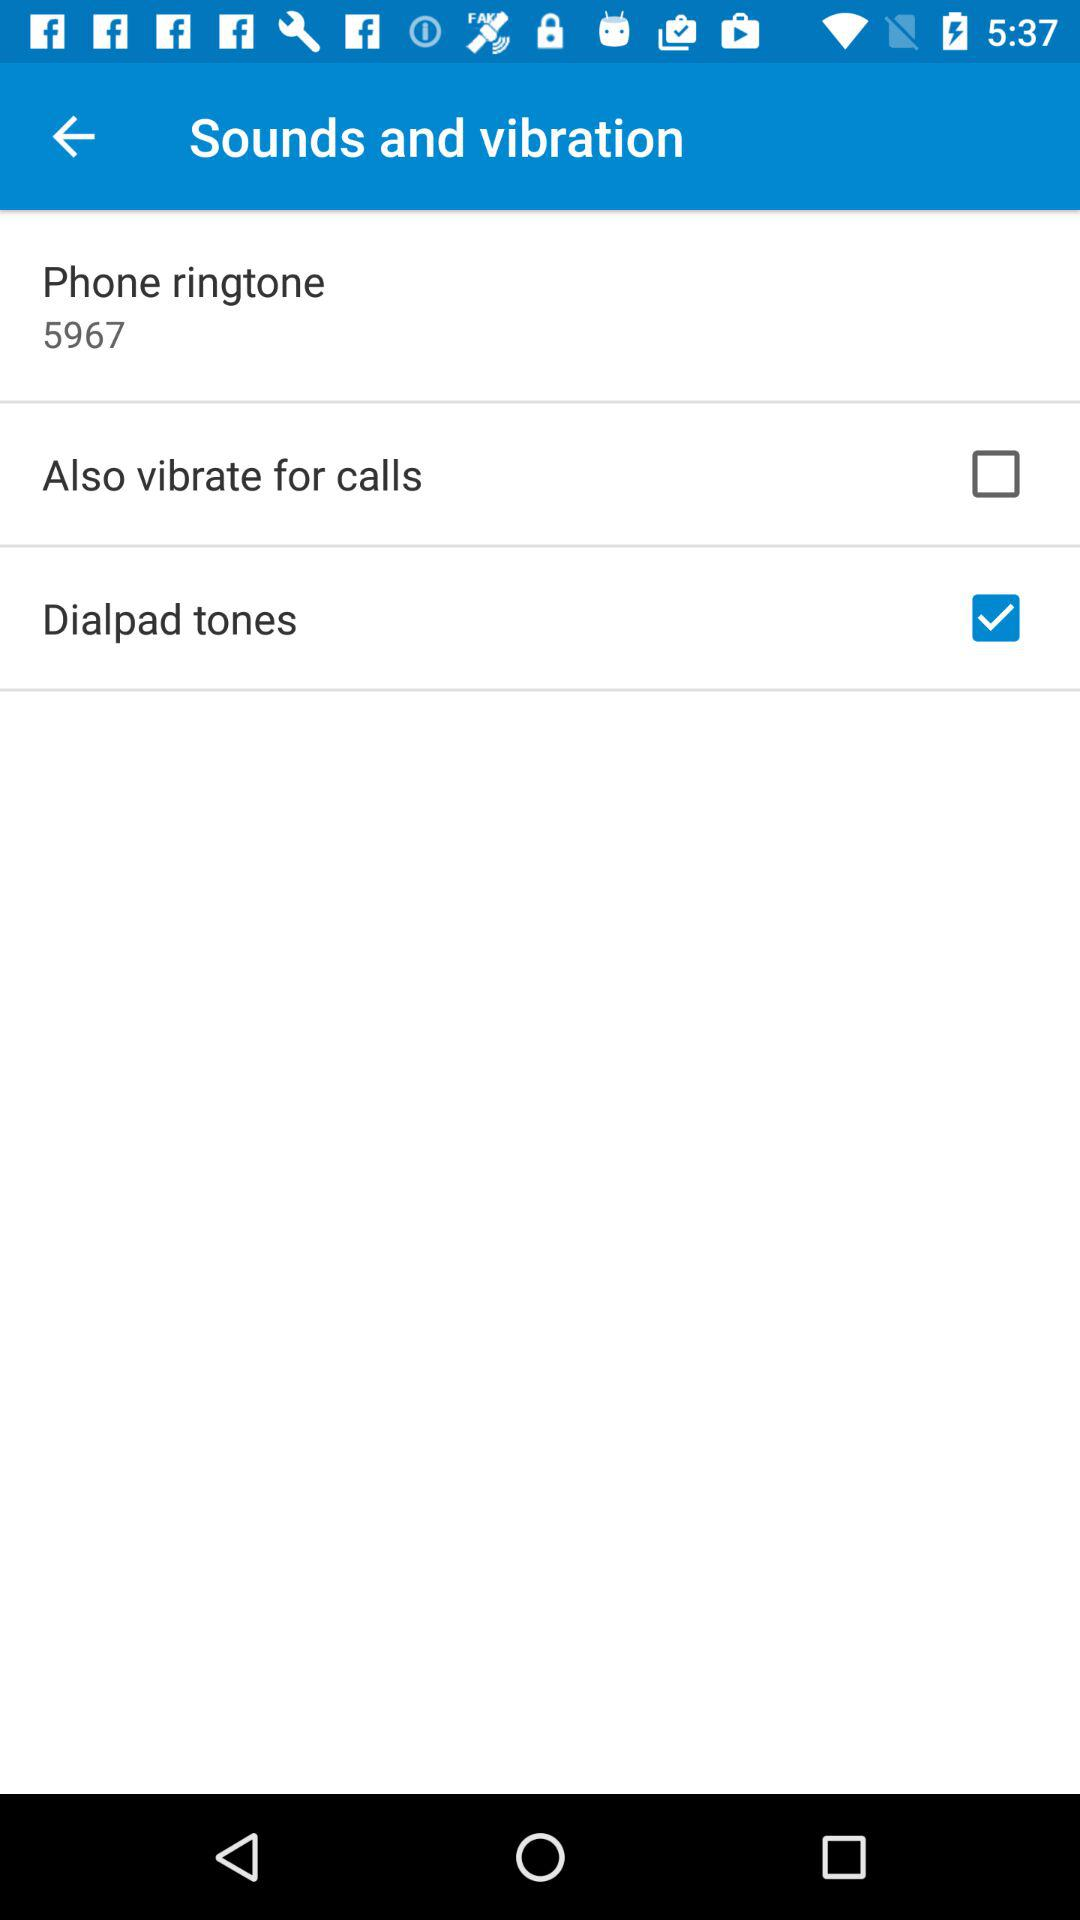What is the status of "Dialpad tones"? The status is "on". 